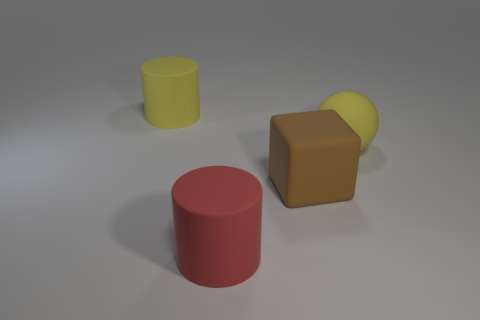Add 1 red cylinders. How many objects exist? 5 Subtract all blocks. How many objects are left? 3 Add 3 brown things. How many brown things are left? 4 Add 1 tiny blue blocks. How many tiny blue blocks exist? 1 Subtract 0 green cylinders. How many objects are left? 4 Subtract all large metal spheres. Subtract all big brown things. How many objects are left? 3 